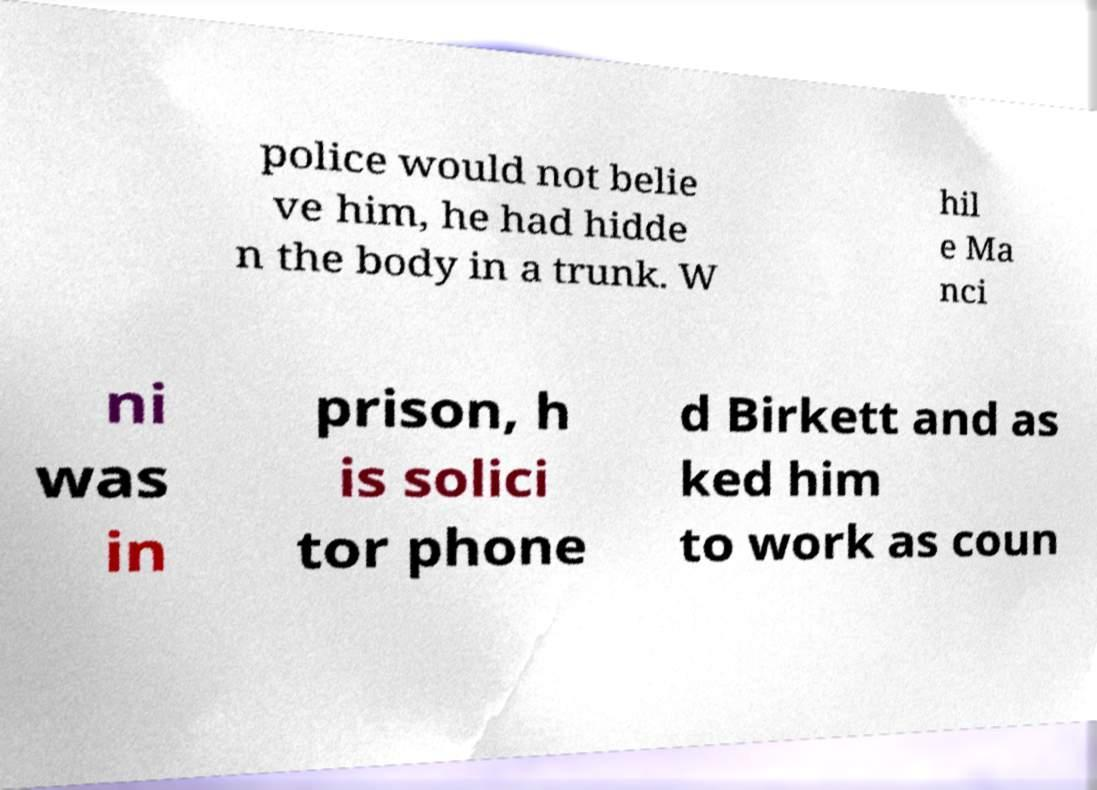Could you assist in decoding the text presented in this image and type it out clearly? police would not belie ve him, he had hidde n the body in a trunk. W hil e Ma nci ni was in prison, h is solici tor phone d Birkett and as ked him to work as coun 